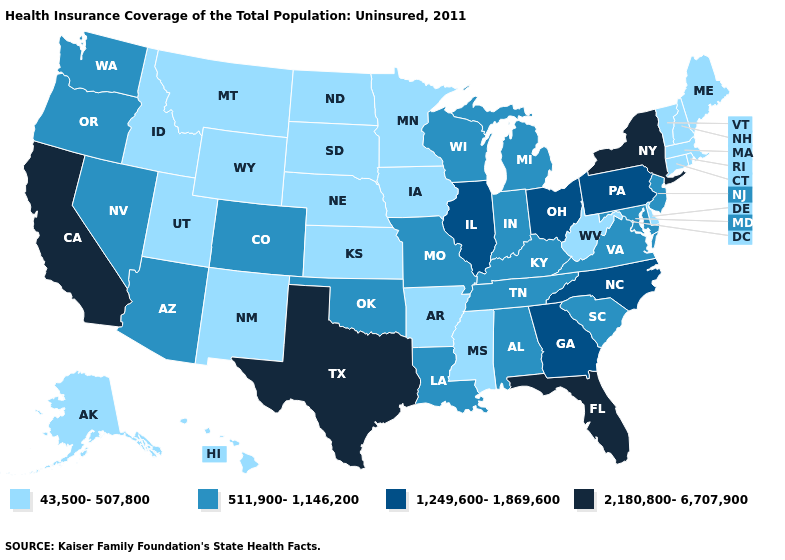Name the states that have a value in the range 1,249,600-1,869,600?
Keep it brief. Georgia, Illinois, North Carolina, Ohio, Pennsylvania. Among the states that border New York , which have the lowest value?
Be succinct. Connecticut, Massachusetts, Vermont. Name the states that have a value in the range 43,500-507,800?
Keep it brief. Alaska, Arkansas, Connecticut, Delaware, Hawaii, Idaho, Iowa, Kansas, Maine, Massachusetts, Minnesota, Mississippi, Montana, Nebraska, New Hampshire, New Mexico, North Dakota, Rhode Island, South Dakota, Utah, Vermont, West Virginia, Wyoming. What is the value of Utah?
Answer briefly. 43,500-507,800. Does West Virginia have a lower value than California?
Short answer required. Yes. Name the states that have a value in the range 43,500-507,800?
Be succinct. Alaska, Arkansas, Connecticut, Delaware, Hawaii, Idaho, Iowa, Kansas, Maine, Massachusetts, Minnesota, Mississippi, Montana, Nebraska, New Hampshire, New Mexico, North Dakota, Rhode Island, South Dakota, Utah, Vermont, West Virginia, Wyoming. Among the states that border Indiana , does Illinois have the lowest value?
Concise answer only. No. What is the lowest value in the USA?
Answer briefly. 43,500-507,800. Among the states that border North Carolina , which have the lowest value?
Be succinct. South Carolina, Tennessee, Virginia. Does Florida have the lowest value in the South?
Give a very brief answer. No. What is the value of New Mexico?
Give a very brief answer. 43,500-507,800. Among the states that border Indiana , does Kentucky have the lowest value?
Concise answer only. Yes. What is the value of Virginia?
Answer briefly. 511,900-1,146,200. Name the states that have a value in the range 511,900-1,146,200?
Short answer required. Alabama, Arizona, Colorado, Indiana, Kentucky, Louisiana, Maryland, Michigan, Missouri, Nevada, New Jersey, Oklahoma, Oregon, South Carolina, Tennessee, Virginia, Washington, Wisconsin. What is the value of Tennessee?
Answer briefly. 511,900-1,146,200. 